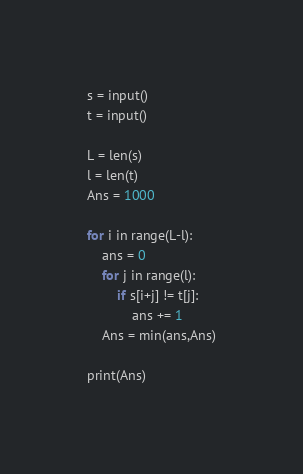<code> <loc_0><loc_0><loc_500><loc_500><_Python_>s = input()
t = input()

L = len(s)
l = len(t)
Ans = 1000

for i in range(L-l):
    ans = 0
    for j in range(l):
        if s[i+j] != t[j]:
            ans += 1 
    Ans = min(ans,Ans)

print(Ans)</code> 